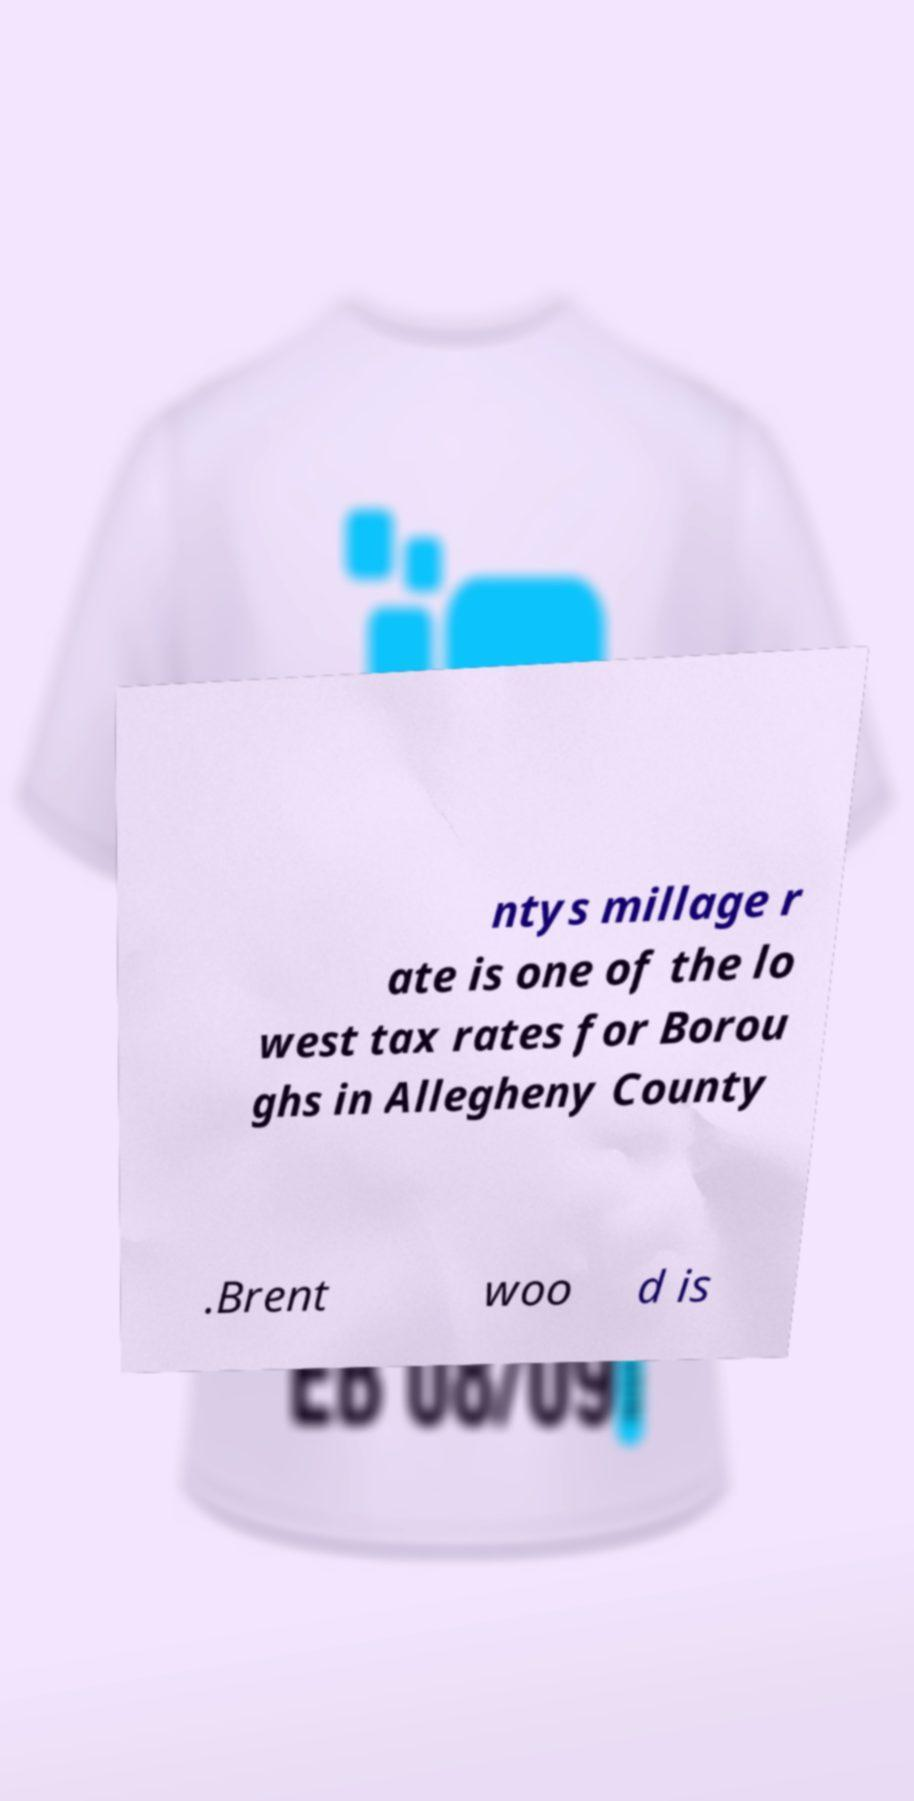There's text embedded in this image that I need extracted. Can you transcribe it verbatim? ntys millage r ate is one of the lo west tax rates for Borou ghs in Allegheny County .Brent woo d is 